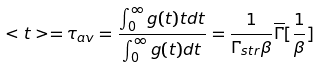<formula> <loc_0><loc_0><loc_500><loc_500>< t > = \tau _ { a v } = \frac { \int _ { 0 } ^ { \infty } g ( t ) t d t } { \int _ { 0 } ^ { \infty } g ( t ) d t } = \frac { 1 } { \Gamma _ { s t r } \beta } \overline { \Gamma } [ \frac { 1 } { \beta } ]</formula> 